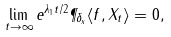<formula> <loc_0><loc_0><loc_500><loc_500>\lim _ { t \to \infty } e ^ { \lambda _ { 1 } t / 2 } \P _ { \delta _ { x } } \langle f , X _ { t } \rangle = 0 ,</formula> 